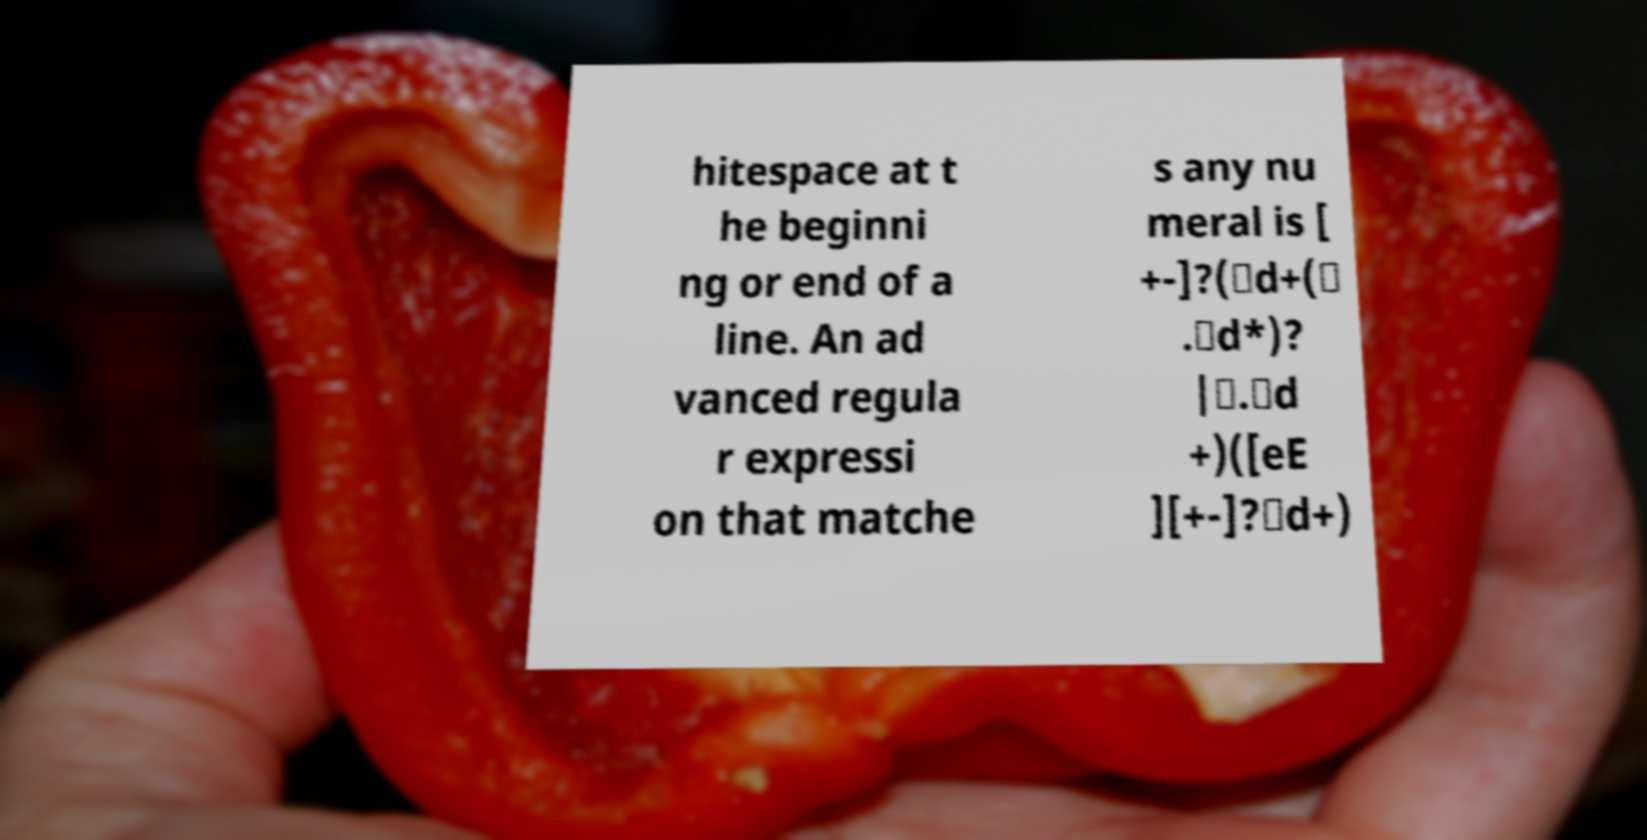Can you read and provide the text displayed in the image?This photo seems to have some interesting text. Can you extract and type it out for me? hitespace at t he beginni ng or end of a line. An ad vanced regula r expressi on that matche s any nu meral is [ +-]?(\d+(\ .\d*)? |\.\d +)([eE ][+-]?\d+) 